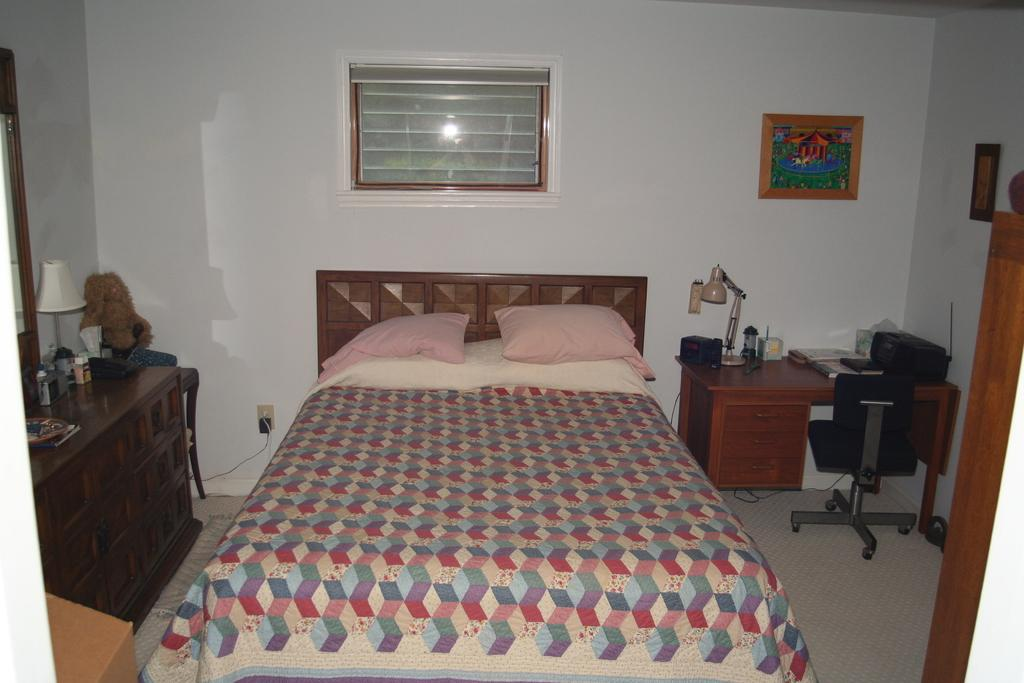What piece of furniture is present in the image? There is a bed in the image. What is covering the bed? There is a blanket on the bed. What are the pillows used for on the bed? The pillows are used for support and comfort while sleeping or resting. What reflective object is in the image? There is a mirror in the image. What is displayed in a frame in the image? There is a photo frame in the image. What type of vest is hanging on the mirror in the image? There is no vest present in the image; only a bed, blanket, pillows, mirror, and photo frame are visible. 